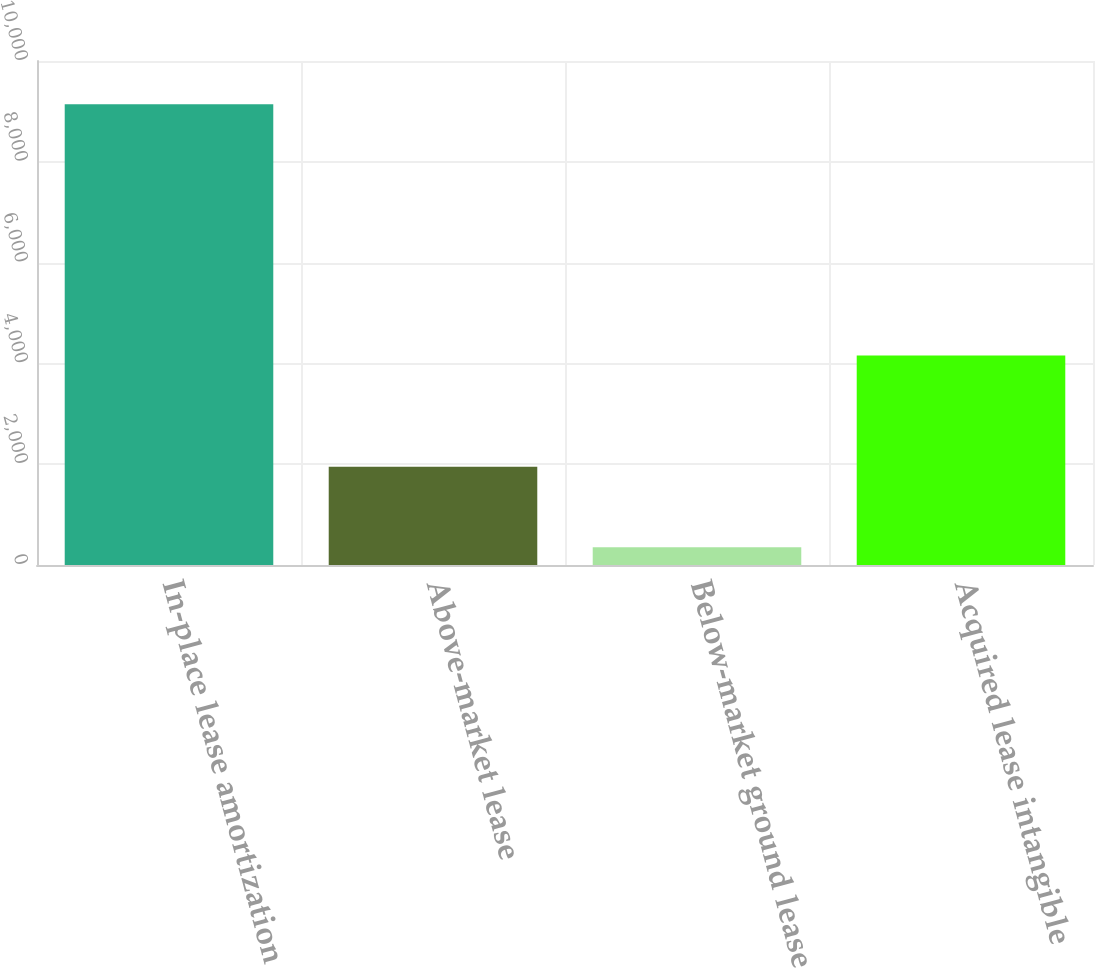Convert chart. <chart><loc_0><loc_0><loc_500><loc_500><bar_chart><fcel>In-place lease amortization<fcel>Above-market lease<fcel>Below-market ground lease<fcel>Acquired lease intangible<nl><fcel>9141<fcel>1950<fcel>351<fcel>4155<nl></chart> 